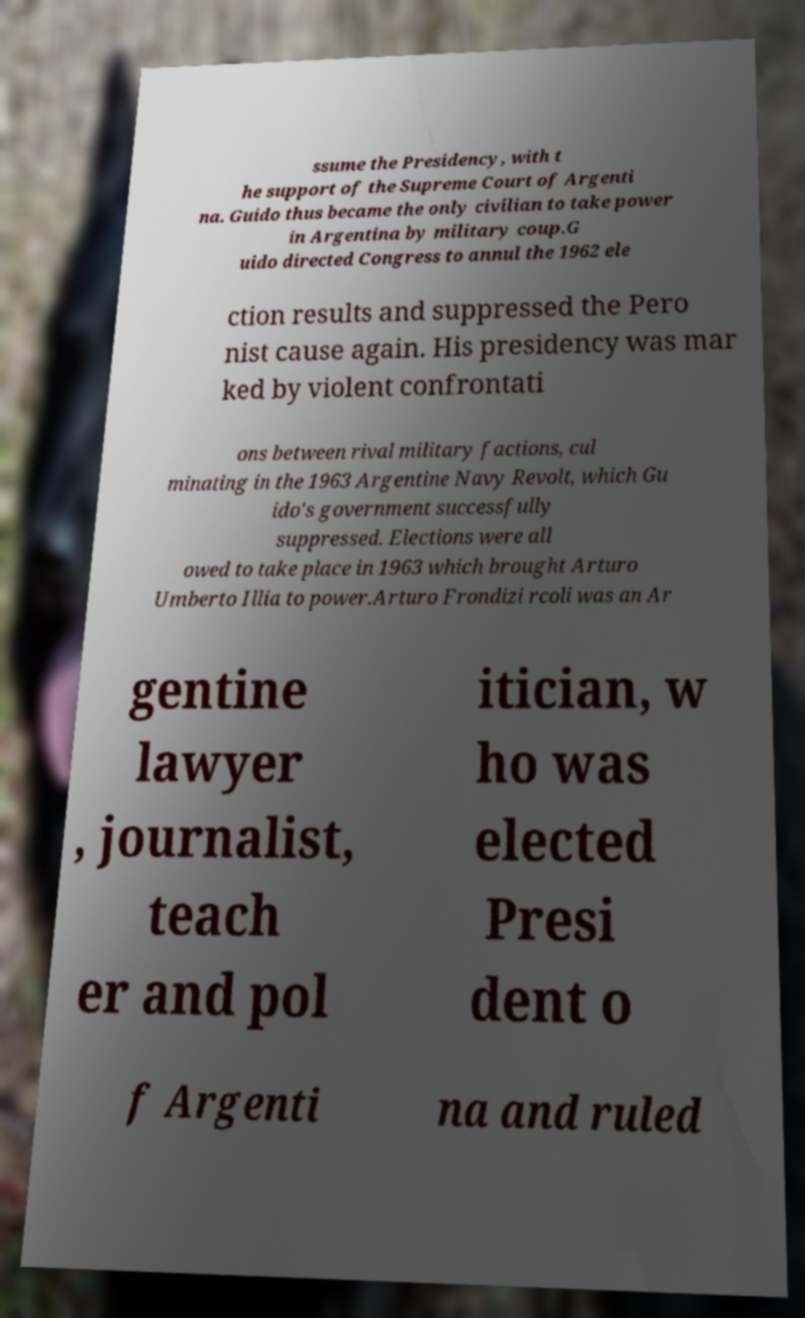I need the written content from this picture converted into text. Can you do that? ssume the Presidency, with t he support of the Supreme Court of Argenti na. Guido thus became the only civilian to take power in Argentina by military coup.G uido directed Congress to annul the 1962 ele ction results and suppressed the Pero nist cause again. His presidency was mar ked by violent confrontati ons between rival military factions, cul minating in the 1963 Argentine Navy Revolt, which Gu ido's government successfully suppressed. Elections were all owed to take place in 1963 which brought Arturo Umberto Illia to power.Arturo Frondizi rcoli was an Ar gentine lawyer , journalist, teach er and pol itician, w ho was elected Presi dent o f Argenti na and ruled 